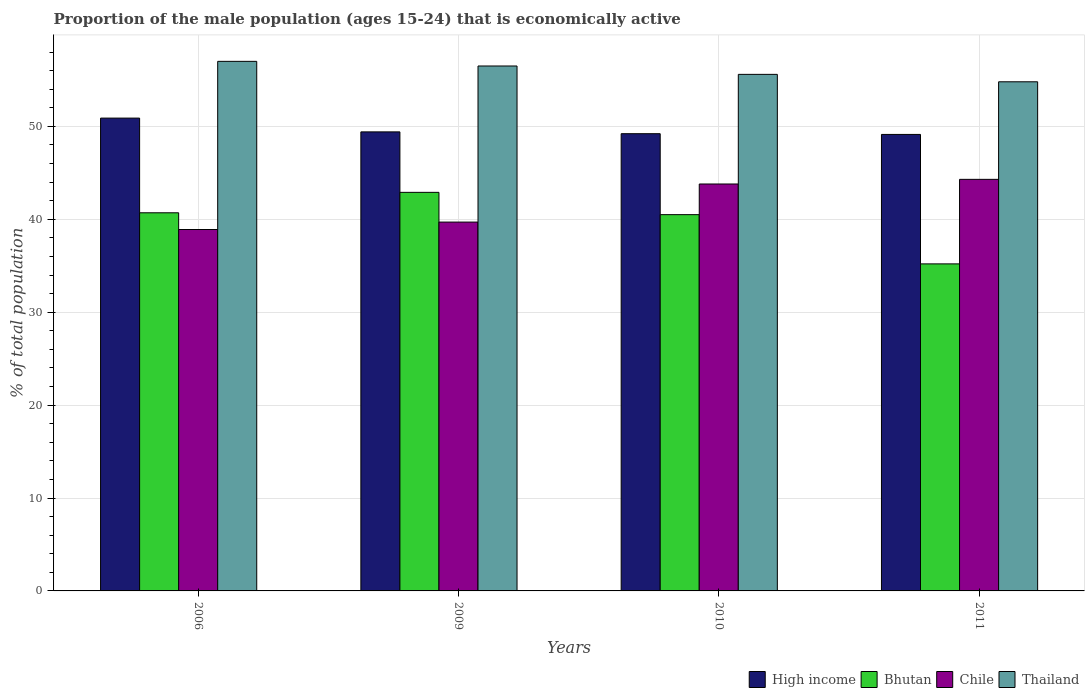How many different coloured bars are there?
Your answer should be very brief. 4. How many groups of bars are there?
Keep it short and to the point. 4. What is the label of the 2nd group of bars from the left?
Give a very brief answer. 2009. Across all years, what is the maximum proportion of the male population that is economically active in High income?
Your answer should be compact. 50.89. Across all years, what is the minimum proportion of the male population that is economically active in Chile?
Give a very brief answer. 38.9. In which year was the proportion of the male population that is economically active in Chile maximum?
Make the answer very short. 2011. In which year was the proportion of the male population that is economically active in High income minimum?
Make the answer very short. 2011. What is the total proportion of the male population that is economically active in Bhutan in the graph?
Your answer should be compact. 159.3. What is the difference between the proportion of the male population that is economically active in Chile in 2006 and that in 2009?
Ensure brevity in your answer.  -0.8. What is the difference between the proportion of the male population that is economically active in Bhutan in 2010 and the proportion of the male population that is economically active in Thailand in 2006?
Your response must be concise. -16.5. What is the average proportion of the male population that is economically active in Thailand per year?
Keep it short and to the point. 55.97. In the year 2011, what is the difference between the proportion of the male population that is economically active in High income and proportion of the male population that is economically active in Chile?
Give a very brief answer. 4.83. What is the ratio of the proportion of the male population that is economically active in Bhutan in 2009 to that in 2010?
Your answer should be compact. 1.06. Is the proportion of the male population that is economically active in Thailand in 2006 less than that in 2011?
Offer a terse response. No. Is the difference between the proportion of the male population that is economically active in High income in 2010 and 2011 greater than the difference between the proportion of the male population that is economically active in Chile in 2010 and 2011?
Keep it short and to the point. Yes. What is the difference between the highest and the second highest proportion of the male population that is economically active in High income?
Your response must be concise. 1.48. What is the difference between the highest and the lowest proportion of the male population that is economically active in Chile?
Provide a short and direct response. 5.4. In how many years, is the proportion of the male population that is economically active in Thailand greater than the average proportion of the male population that is economically active in Thailand taken over all years?
Give a very brief answer. 2. Is the sum of the proportion of the male population that is economically active in Chile in 2009 and 2010 greater than the maximum proportion of the male population that is economically active in Thailand across all years?
Keep it short and to the point. Yes. Is it the case that in every year, the sum of the proportion of the male population that is economically active in Thailand and proportion of the male population that is economically active in Bhutan is greater than the sum of proportion of the male population that is economically active in Chile and proportion of the male population that is economically active in High income?
Provide a short and direct response. Yes. What does the 4th bar from the left in 2009 represents?
Your answer should be very brief. Thailand. What does the 4th bar from the right in 2010 represents?
Keep it short and to the point. High income. Are all the bars in the graph horizontal?
Provide a short and direct response. No. Are the values on the major ticks of Y-axis written in scientific E-notation?
Ensure brevity in your answer.  No. Does the graph contain grids?
Make the answer very short. Yes. Where does the legend appear in the graph?
Provide a short and direct response. Bottom right. How are the legend labels stacked?
Your response must be concise. Horizontal. What is the title of the graph?
Your response must be concise. Proportion of the male population (ages 15-24) that is economically active. What is the label or title of the Y-axis?
Make the answer very short. % of total population. What is the % of total population of High income in 2006?
Offer a terse response. 50.89. What is the % of total population in Bhutan in 2006?
Offer a terse response. 40.7. What is the % of total population in Chile in 2006?
Ensure brevity in your answer.  38.9. What is the % of total population of High income in 2009?
Provide a succinct answer. 49.41. What is the % of total population in Bhutan in 2009?
Provide a succinct answer. 42.9. What is the % of total population of Chile in 2009?
Give a very brief answer. 39.7. What is the % of total population in Thailand in 2009?
Your answer should be very brief. 56.5. What is the % of total population of High income in 2010?
Provide a short and direct response. 49.21. What is the % of total population of Bhutan in 2010?
Offer a terse response. 40.5. What is the % of total population of Chile in 2010?
Offer a terse response. 43.8. What is the % of total population in Thailand in 2010?
Give a very brief answer. 55.6. What is the % of total population in High income in 2011?
Your response must be concise. 49.13. What is the % of total population in Bhutan in 2011?
Offer a very short reply. 35.2. What is the % of total population in Chile in 2011?
Make the answer very short. 44.3. What is the % of total population in Thailand in 2011?
Provide a short and direct response. 54.8. Across all years, what is the maximum % of total population of High income?
Offer a very short reply. 50.89. Across all years, what is the maximum % of total population of Bhutan?
Provide a short and direct response. 42.9. Across all years, what is the maximum % of total population of Chile?
Keep it short and to the point. 44.3. Across all years, what is the minimum % of total population in High income?
Provide a short and direct response. 49.13. Across all years, what is the minimum % of total population in Bhutan?
Provide a short and direct response. 35.2. Across all years, what is the minimum % of total population in Chile?
Make the answer very short. 38.9. Across all years, what is the minimum % of total population of Thailand?
Provide a short and direct response. 54.8. What is the total % of total population in High income in the graph?
Your answer should be compact. 198.65. What is the total % of total population in Bhutan in the graph?
Offer a very short reply. 159.3. What is the total % of total population in Chile in the graph?
Offer a terse response. 166.7. What is the total % of total population in Thailand in the graph?
Ensure brevity in your answer.  223.9. What is the difference between the % of total population of High income in 2006 and that in 2009?
Your answer should be compact. 1.48. What is the difference between the % of total population of Bhutan in 2006 and that in 2009?
Your answer should be very brief. -2.2. What is the difference between the % of total population in Chile in 2006 and that in 2009?
Keep it short and to the point. -0.8. What is the difference between the % of total population in Thailand in 2006 and that in 2009?
Offer a terse response. 0.5. What is the difference between the % of total population of High income in 2006 and that in 2010?
Your response must be concise. 1.68. What is the difference between the % of total population of Chile in 2006 and that in 2010?
Ensure brevity in your answer.  -4.9. What is the difference between the % of total population in High income in 2006 and that in 2011?
Provide a short and direct response. 1.76. What is the difference between the % of total population of Thailand in 2006 and that in 2011?
Your answer should be very brief. 2.2. What is the difference between the % of total population of High income in 2009 and that in 2010?
Give a very brief answer. 0.2. What is the difference between the % of total population in Thailand in 2009 and that in 2010?
Offer a terse response. 0.9. What is the difference between the % of total population in High income in 2009 and that in 2011?
Give a very brief answer. 0.27. What is the difference between the % of total population in Bhutan in 2009 and that in 2011?
Your answer should be very brief. 7.7. What is the difference between the % of total population of Thailand in 2009 and that in 2011?
Your answer should be compact. 1.7. What is the difference between the % of total population in High income in 2010 and that in 2011?
Give a very brief answer. 0.08. What is the difference between the % of total population in Bhutan in 2010 and that in 2011?
Your answer should be very brief. 5.3. What is the difference between the % of total population in High income in 2006 and the % of total population in Bhutan in 2009?
Provide a short and direct response. 7.99. What is the difference between the % of total population of High income in 2006 and the % of total population of Chile in 2009?
Offer a very short reply. 11.19. What is the difference between the % of total population in High income in 2006 and the % of total population in Thailand in 2009?
Provide a short and direct response. -5.61. What is the difference between the % of total population in Bhutan in 2006 and the % of total population in Thailand in 2009?
Your response must be concise. -15.8. What is the difference between the % of total population of Chile in 2006 and the % of total population of Thailand in 2009?
Provide a short and direct response. -17.6. What is the difference between the % of total population in High income in 2006 and the % of total population in Bhutan in 2010?
Provide a succinct answer. 10.39. What is the difference between the % of total population in High income in 2006 and the % of total population in Chile in 2010?
Offer a very short reply. 7.09. What is the difference between the % of total population in High income in 2006 and the % of total population in Thailand in 2010?
Offer a terse response. -4.71. What is the difference between the % of total population of Bhutan in 2006 and the % of total population of Thailand in 2010?
Offer a very short reply. -14.9. What is the difference between the % of total population of Chile in 2006 and the % of total population of Thailand in 2010?
Your answer should be very brief. -16.7. What is the difference between the % of total population of High income in 2006 and the % of total population of Bhutan in 2011?
Your response must be concise. 15.69. What is the difference between the % of total population of High income in 2006 and the % of total population of Chile in 2011?
Your answer should be very brief. 6.59. What is the difference between the % of total population of High income in 2006 and the % of total population of Thailand in 2011?
Make the answer very short. -3.91. What is the difference between the % of total population of Bhutan in 2006 and the % of total population of Thailand in 2011?
Provide a succinct answer. -14.1. What is the difference between the % of total population in Chile in 2006 and the % of total population in Thailand in 2011?
Offer a very short reply. -15.9. What is the difference between the % of total population of High income in 2009 and the % of total population of Bhutan in 2010?
Give a very brief answer. 8.91. What is the difference between the % of total population of High income in 2009 and the % of total population of Chile in 2010?
Give a very brief answer. 5.61. What is the difference between the % of total population in High income in 2009 and the % of total population in Thailand in 2010?
Offer a terse response. -6.19. What is the difference between the % of total population of Bhutan in 2009 and the % of total population of Thailand in 2010?
Offer a very short reply. -12.7. What is the difference between the % of total population in Chile in 2009 and the % of total population in Thailand in 2010?
Provide a succinct answer. -15.9. What is the difference between the % of total population of High income in 2009 and the % of total population of Bhutan in 2011?
Your answer should be very brief. 14.21. What is the difference between the % of total population in High income in 2009 and the % of total population in Chile in 2011?
Your answer should be very brief. 5.11. What is the difference between the % of total population in High income in 2009 and the % of total population in Thailand in 2011?
Provide a succinct answer. -5.39. What is the difference between the % of total population in Bhutan in 2009 and the % of total population in Thailand in 2011?
Make the answer very short. -11.9. What is the difference between the % of total population in Chile in 2009 and the % of total population in Thailand in 2011?
Keep it short and to the point. -15.1. What is the difference between the % of total population in High income in 2010 and the % of total population in Bhutan in 2011?
Offer a very short reply. 14.01. What is the difference between the % of total population of High income in 2010 and the % of total population of Chile in 2011?
Offer a terse response. 4.91. What is the difference between the % of total population of High income in 2010 and the % of total population of Thailand in 2011?
Make the answer very short. -5.59. What is the difference between the % of total population of Bhutan in 2010 and the % of total population of Chile in 2011?
Your answer should be compact. -3.8. What is the difference between the % of total population of Bhutan in 2010 and the % of total population of Thailand in 2011?
Give a very brief answer. -14.3. What is the difference between the % of total population of Chile in 2010 and the % of total population of Thailand in 2011?
Offer a terse response. -11. What is the average % of total population of High income per year?
Your response must be concise. 49.66. What is the average % of total population of Bhutan per year?
Provide a succinct answer. 39.83. What is the average % of total population of Chile per year?
Your answer should be very brief. 41.67. What is the average % of total population in Thailand per year?
Offer a very short reply. 55.98. In the year 2006, what is the difference between the % of total population of High income and % of total population of Bhutan?
Your answer should be compact. 10.19. In the year 2006, what is the difference between the % of total population in High income and % of total population in Chile?
Provide a short and direct response. 11.99. In the year 2006, what is the difference between the % of total population of High income and % of total population of Thailand?
Your answer should be very brief. -6.11. In the year 2006, what is the difference between the % of total population in Bhutan and % of total population in Chile?
Your response must be concise. 1.8. In the year 2006, what is the difference between the % of total population in Bhutan and % of total population in Thailand?
Offer a very short reply. -16.3. In the year 2006, what is the difference between the % of total population of Chile and % of total population of Thailand?
Offer a terse response. -18.1. In the year 2009, what is the difference between the % of total population in High income and % of total population in Bhutan?
Make the answer very short. 6.51. In the year 2009, what is the difference between the % of total population of High income and % of total population of Chile?
Your answer should be very brief. 9.71. In the year 2009, what is the difference between the % of total population of High income and % of total population of Thailand?
Offer a terse response. -7.09. In the year 2009, what is the difference between the % of total population in Bhutan and % of total population in Thailand?
Provide a short and direct response. -13.6. In the year 2009, what is the difference between the % of total population of Chile and % of total population of Thailand?
Your answer should be compact. -16.8. In the year 2010, what is the difference between the % of total population in High income and % of total population in Bhutan?
Offer a terse response. 8.71. In the year 2010, what is the difference between the % of total population in High income and % of total population in Chile?
Provide a short and direct response. 5.41. In the year 2010, what is the difference between the % of total population of High income and % of total population of Thailand?
Keep it short and to the point. -6.39. In the year 2010, what is the difference between the % of total population in Bhutan and % of total population in Chile?
Your answer should be very brief. -3.3. In the year 2010, what is the difference between the % of total population of Bhutan and % of total population of Thailand?
Provide a short and direct response. -15.1. In the year 2011, what is the difference between the % of total population in High income and % of total population in Bhutan?
Make the answer very short. 13.93. In the year 2011, what is the difference between the % of total population in High income and % of total population in Chile?
Offer a very short reply. 4.83. In the year 2011, what is the difference between the % of total population of High income and % of total population of Thailand?
Your answer should be compact. -5.67. In the year 2011, what is the difference between the % of total population in Bhutan and % of total population in Thailand?
Ensure brevity in your answer.  -19.6. In the year 2011, what is the difference between the % of total population of Chile and % of total population of Thailand?
Give a very brief answer. -10.5. What is the ratio of the % of total population of Bhutan in 2006 to that in 2009?
Make the answer very short. 0.95. What is the ratio of the % of total population of Chile in 2006 to that in 2009?
Your response must be concise. 0.98. What is the ratio of the % of total population in Thailand in 2006 to that in 2009?
Provide a succinct answer. 1.01. What is the ratio of the % of total population in High income in 2006 to that in 2010?
Ensure brevity in your answer.  1.03. What is the ratio of the % of total population in Chile in 2006 to that in 2010?
Keep it short and to the point. 0.89. What is the ratio of the % of total population of Thailand in 2006 to that in 2010?
Offer a very short reply. 1.03. What is the ratio of the % of total population of High income in 2006 to that in 2011?
Give a very brief answer. 1.04. What is the ratio of the % of total population of Bhutan in 2006 to that in 2011?
Ensure brevity in your answer.  1.16. What is the ratio of the % of total population in Chile in 2006 to that in 2011?
Provide a short and direct response. 0.88. What is the ratio of the % of total population of Thailand in 2006 to that in 2011?
Your answer should be very brief. 1.04. What is the ratio of the % of total population of High income in 2009 to that in 2010?
Make the answer very short. 1. What is the ratio of the % of total population in Bhutan in 2009 to that in 2010?
Your response must be concise. 1.06. What is the ratio of the % of total population in Chile in 2009 to that in 2010?
Provide a short and direct response. 0.91. What is the ratio of the % of total population of Thailand in 2009 to that in 2010?
Your answer should be very brief. 1.02. What is the ratio of the % of total population of High income in 2009 to that in 2011?
Provide a succinct answer. 1.01. What is the ratio of the % of total population of Bhutan in 2009 to that in 2011?
Your answer should be very brief. 1.22. What is the ratio of the % of total population of Chile in 2009 to that in 2011?
Your answer should be compact. 0.9. What is the ratio of the % of total population of Thailand in 2009 to that in 2011?
Offer a terse response. 1.03. What is the ratio of the % of total population in Bhutan in 2010 to that in 2011?
Your answer should be compact. 1.15. What is the ratio of the % of total population of Chile in 2010 to that in 2011?
Keep it short and to the point. 0.99. What is the ratio of the % of total population in Thailand in 2010 to that in 2011?
Your response must be concise. 1.01. What is the difference between the highest and the second highest % of total population in High income?
Give a very brief answer. 1.48. What is the difference between the highest and the second highest % of total population in Chile?
Your answer should be compact. 0.5. What is the difference between the highest and the second highest % of total population of Thailand?
Give a very brief answer. 0.5. What is the difference between the highest and the lowest % of total population of High income?
Offer a very short reply. 1.76. What is the difference between the highest and the lowest % of total population in Bhutan?
Give a very brief answer. 7.7. What is the difference between the highest and the lowest % of total population in Thailand?
Offer a terse response. 2.2. 